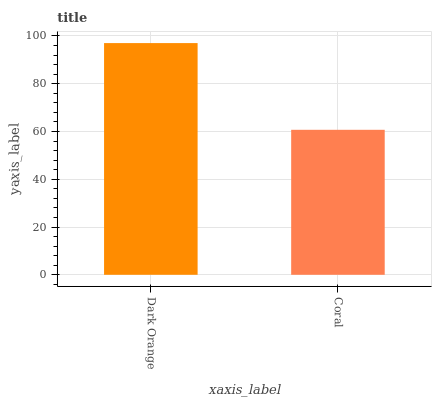Is Coral the minimum?
Answer yes or no. Yes. Is Dark Orange the maximum?
Answer yes or no. Yes. Is Coral the maximum?
Answer yes or no. No. Is Dark Orange greater than Coral?
Answer yes or no. Yes. Is Coral less than Dark Orange?
Answer yes or no. Yes. Is Coral greater than Dark Orange?
Answer yes or no. No. Is Dark Orange less than Coral?
Answer yes or no. No. Is Dark Orange the high median?
Answer yes or no. Yes. Is Coral the low median?
Answer yes or no. Yes. Is Coral the high median?
Answer yes or no. No. Is Dark Orange the low median?
Answer yes or no. No. 